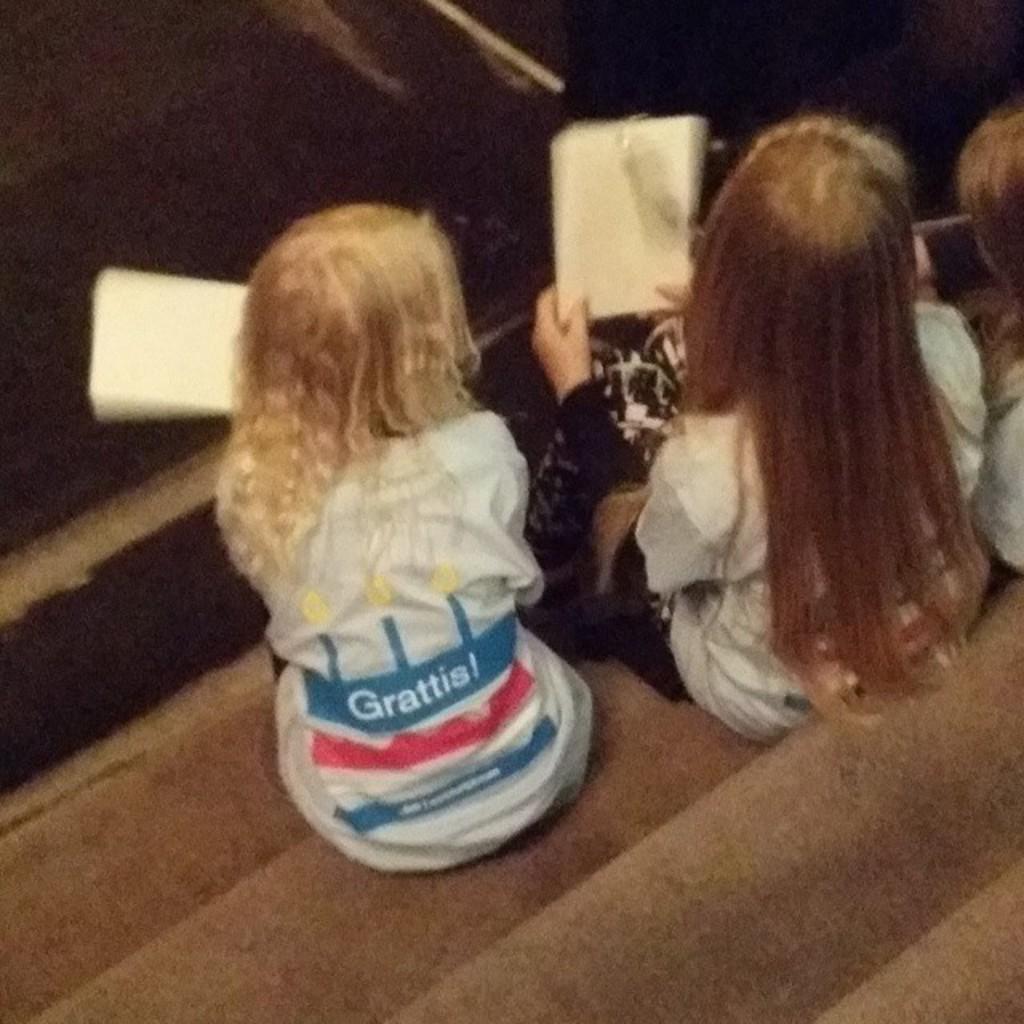How would you summarize this image in a sentence or two? In the picture I can see three girls sitting on the staircase and two of them holding the book in their hands. 